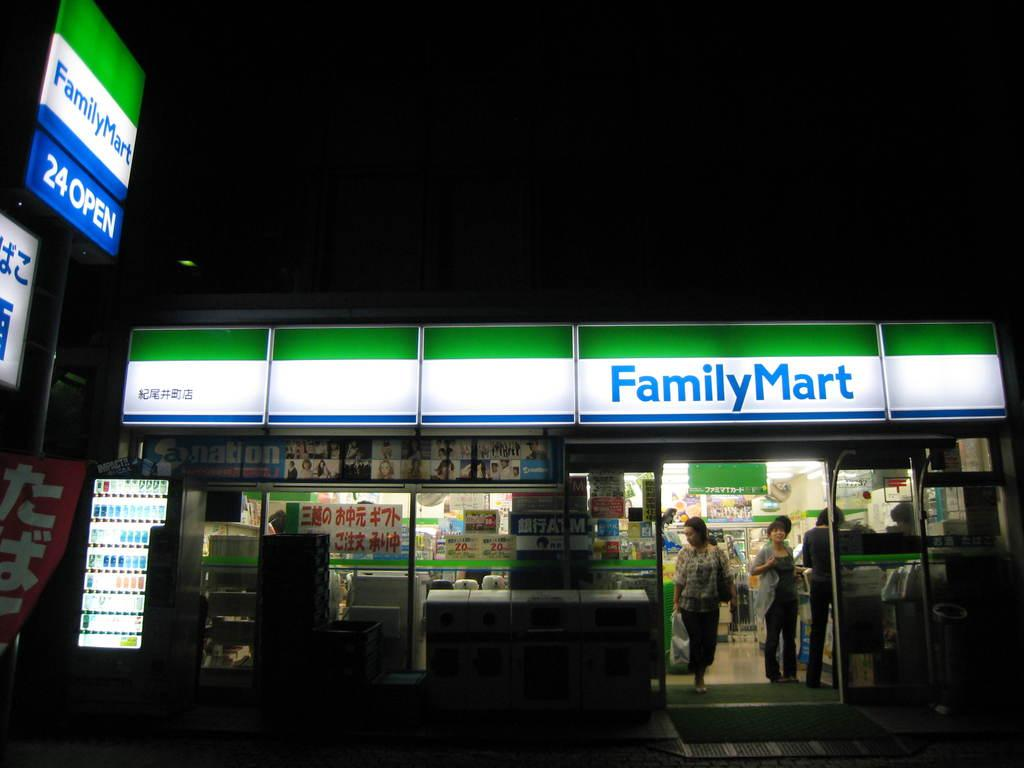<image>
Describe the image concisely. the entrance of Family Mart is lllit up well 